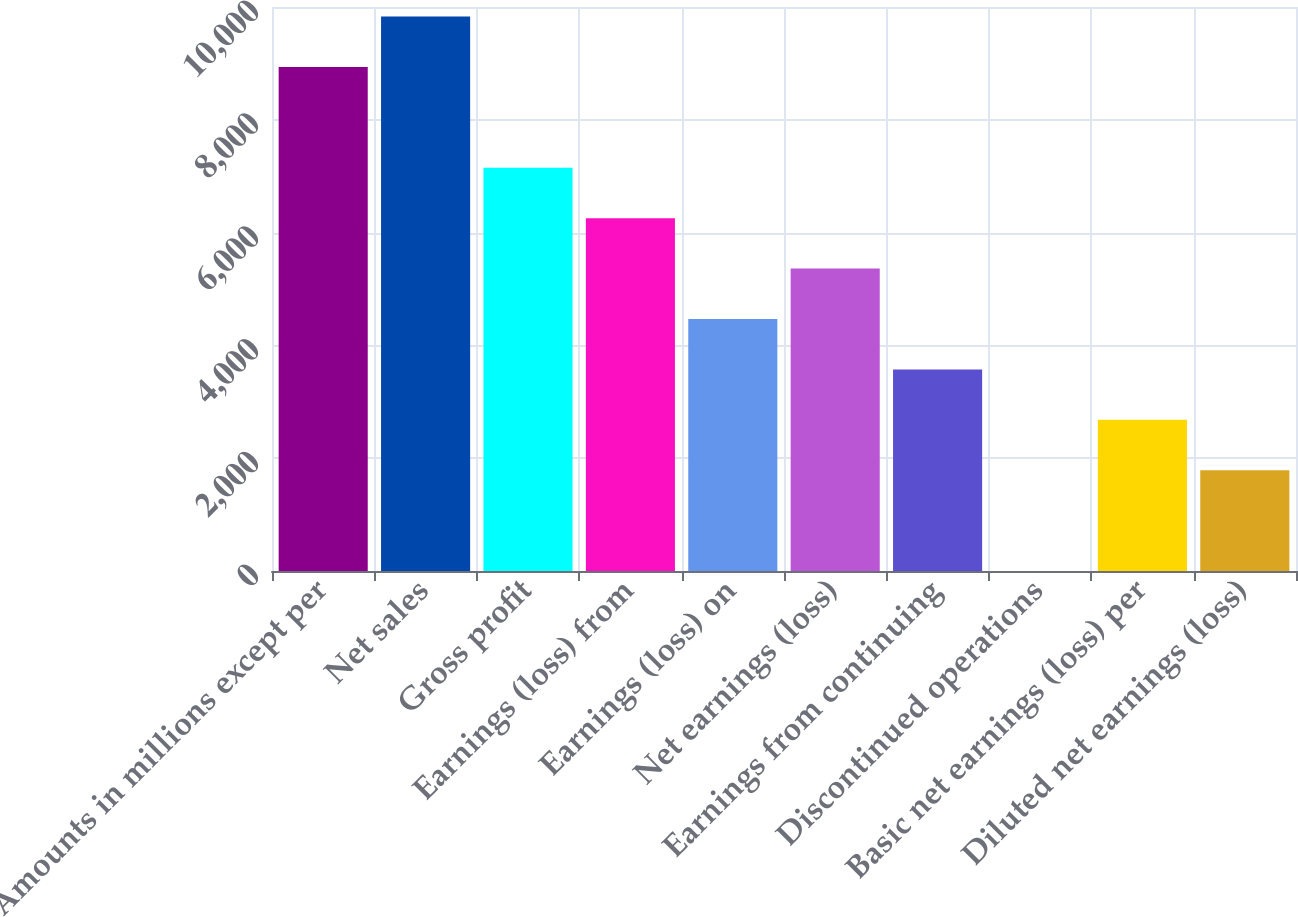Convert chart to OTSL. <chart><loc_0><loc_0><loc_500><loc_500><bar_chart><fcel>Amounts in millions except per<fcel>Net sales<fcel>Gross profit<fcel>Earnings (loss) from<fcel>Earnings (loss) on<fcel>Net earnings (loss)<fcel>Earnings from continuing<fcel>Discontinued operations<fcel>Basic net earnings (loss) per<fcel>Diluted net earnings (loss)<nl><fcel>8936.42<fcel>9830.05<fcel>7149.16<fcel>6255.53<fcel>4468.27<fcel>5361.9<fcel>3574.64<fcel>0.12<fcel>2681.01<fcel>1787.38<nl></chart> 